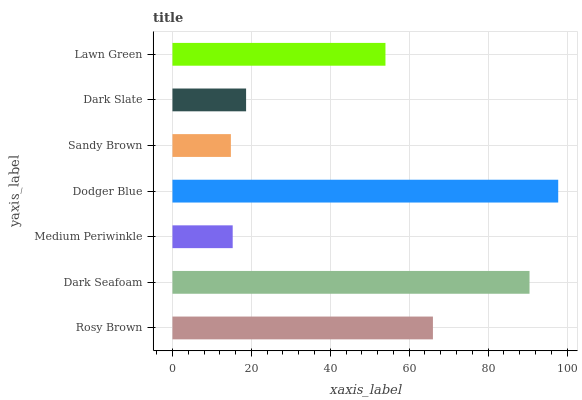Is Sandy Brown the minimum?
Answer yes or no. Yes. Is Dodger Blue the maximum?
Answer yes or no. Yes. Is Dark Seafoam the minimum?
Answer yes or no. No. Is Dark Seafoam the maximum?
Answer yes or no. No. Is Dark Seafoam greater than Rosy Brown?
Answer yes or no. Yes. Is Rosy Brown less than Dark Seafoam?
Answer yes or no. Yes. Is Rosy Brown greater than Dark Seafoam?
Answer yes or no. No. Is Dark Seafoam less than Rosy Brown?
Answer yes or no. No. Is Lawn Green the high median?
Answer yes or no. Yes. Is Lawn Green the low median?
Answer yes or no. Yes. Is Dark Slate the high median?
Answer yes or no. No. Is Sandy Brown the low median?
Answer yes or no. No. 